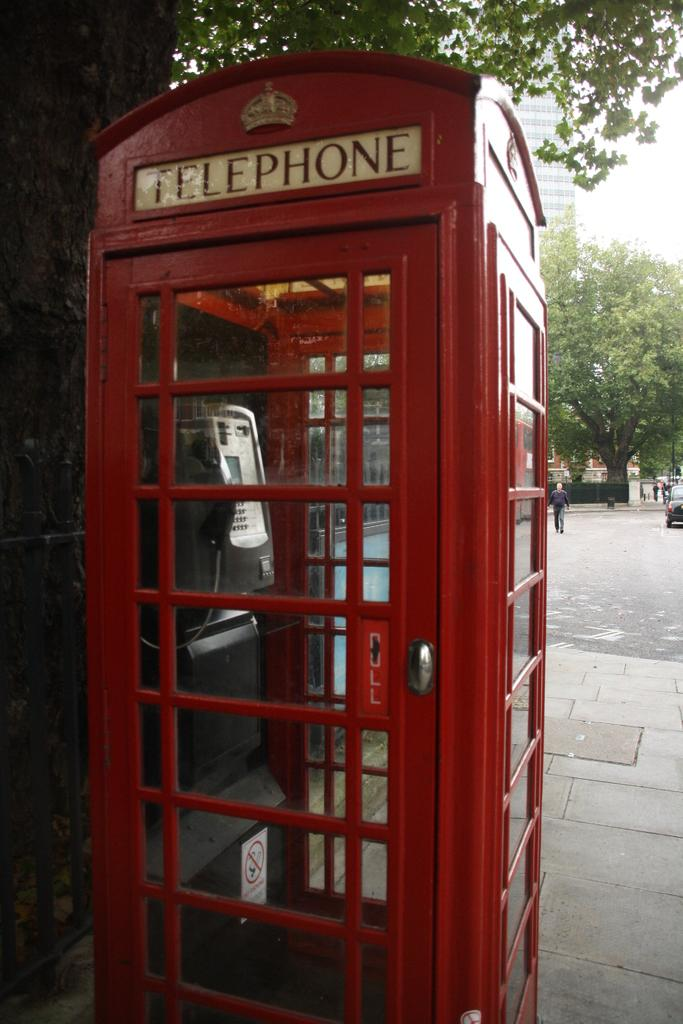<image>
Share a concise interpretation of the image provided. The door of a telephone booth reminds its prospective users to pull it open. 